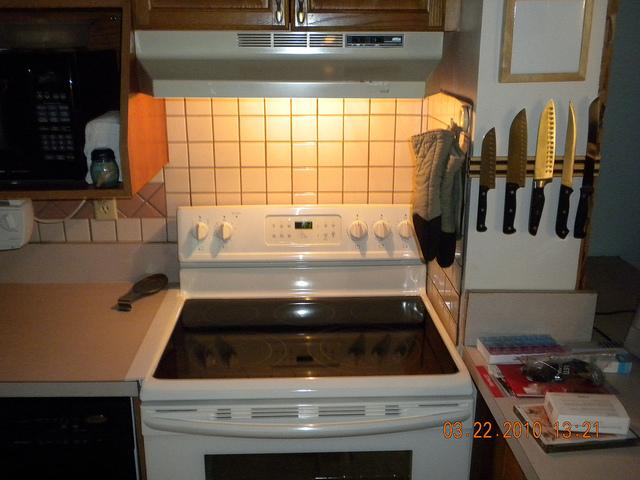Is the stove light on?
Quick response, please. Yes. What color is the microwave?
Be succinct. Black. Is that a stove?
Quick response, please. Yes. 